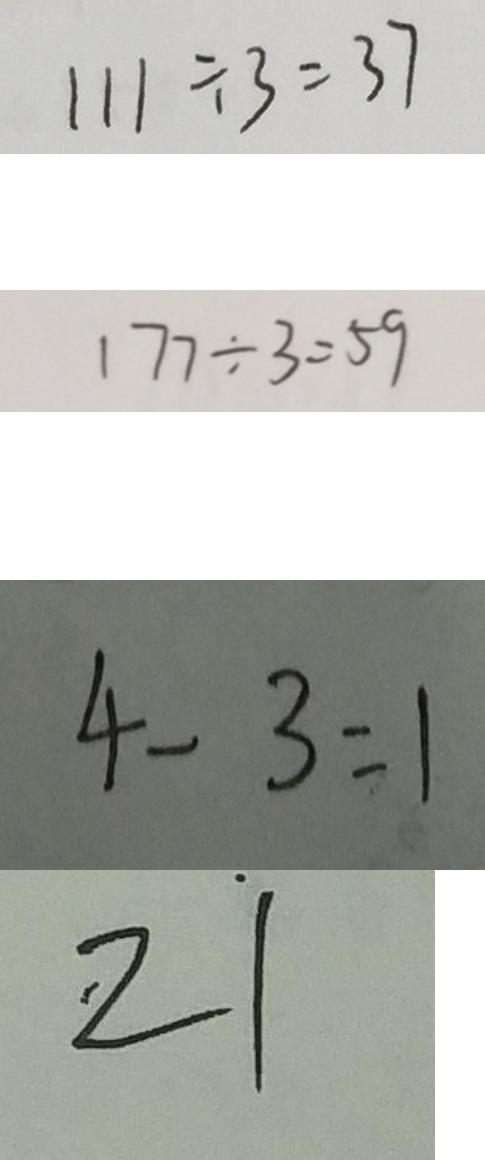Convert formula to latex. <formula><loc_0><loc_0><loc_500><loc_500>1 1 1 \div 3 = 3 7 
 1 7 7 \div 3 = 5 9 
 4 - 3 = 1 
 z \dot { 1 }</formula> 